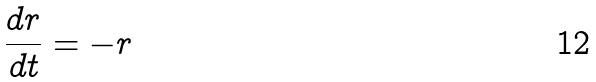<formula> <loc_0><loc_0><loc_500><loc_500>\frac { d r } { d t } = - r</formula> 